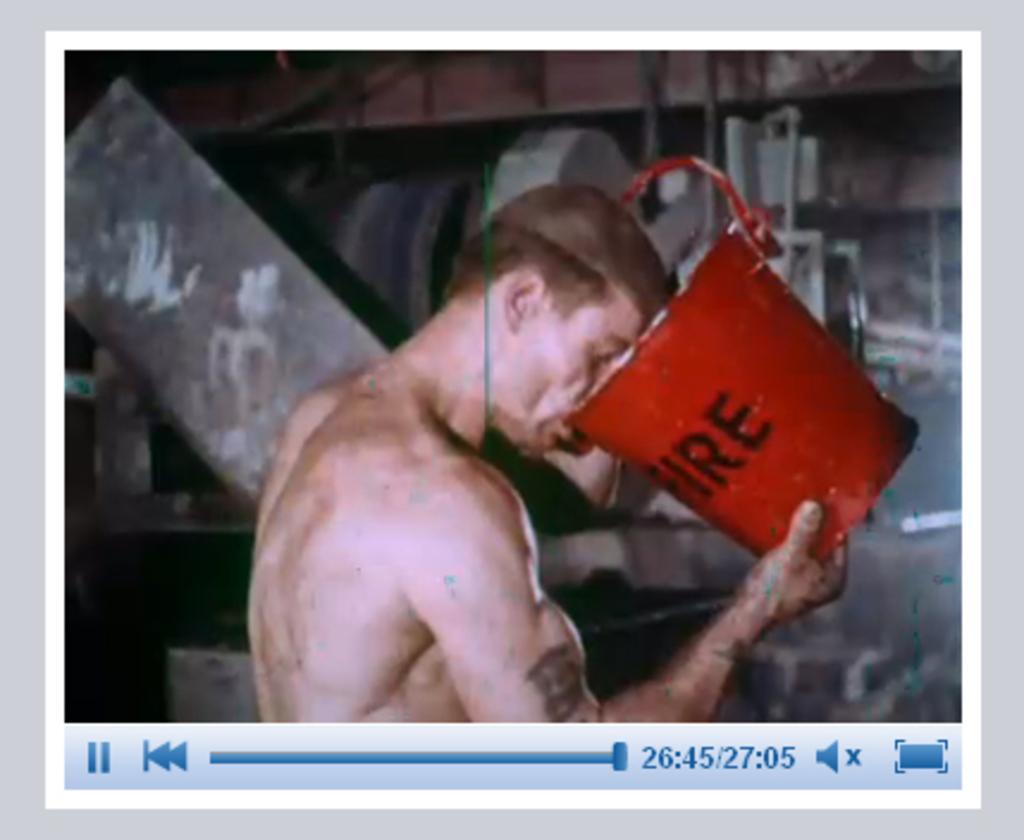How would you summarize this image in a sentence or two? In this image we can see a screen shot of a video clip of a person drinking water from a bucket. 